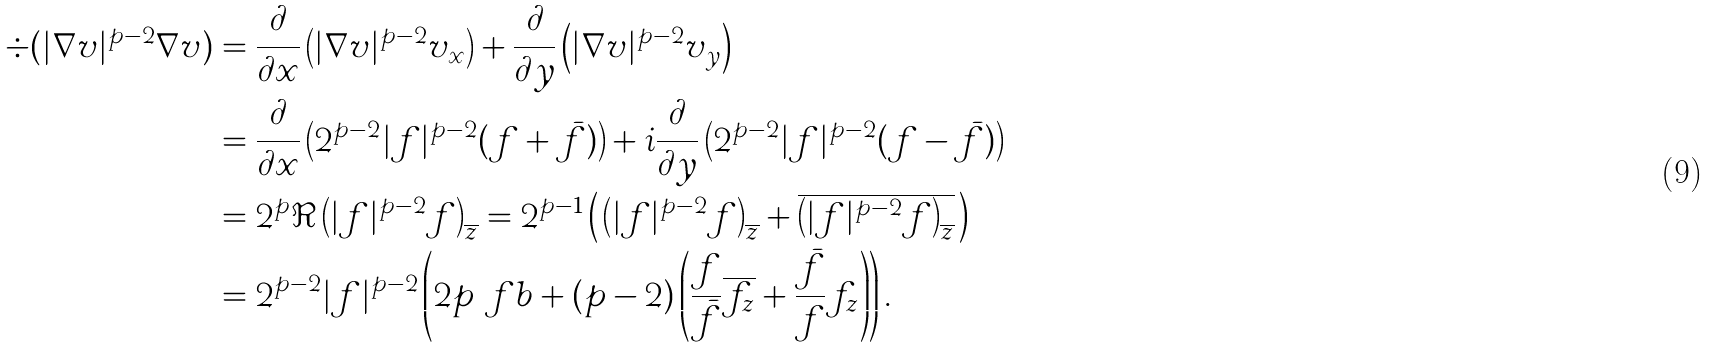<formula> <loc_0><loc_0><loc_500><loc_500>\div ( | \nabla v | ^ { p - 2 } \nabla v ) & = \frac { \partial } { \partial x } \left ( | \nabla v | ^ { p - 2 } v _ { x } \right ) + \frac { \partial } { \partial y } \left ( | \nabla v | ^ { p - 2 } v _ { y } \right ) \\ & = \frac { \partial } { \partial x } \left ( 2 ^ { p - 2 } | f | ^ { p - 2 } ( f + \bar { f } ) \right ) + i \frac { \partial } { \partial y } \left ( 2 ^ { p - 2 } | f | ^ { p - 2 } ( f - \bar { f } ) \right ) \\ & = 2 ^ { p } \Re \left ( | f | ^ { p - 2 } f \right ) _ { \overline { z } } = 2 ^ { p - 1 } \left ( \, \left ( | f | ^ { p - 2 } f \right ) _ { \overline { z } } + \overline { \left ( | f | ^ { p - 2 } f \right ) _ { \overline { z } } } \, \right ) \\ & = 2 ^ { p - 2 } | f | ^ { p - 2 } \left ( 2 p \ f b + ( p - 2 ) \left ( \frac { f } { \bar { f } } \overline { f _ { z } } + \frac { \bar { f } } { f } f _ { z } \right ) \right ) .</formula> 